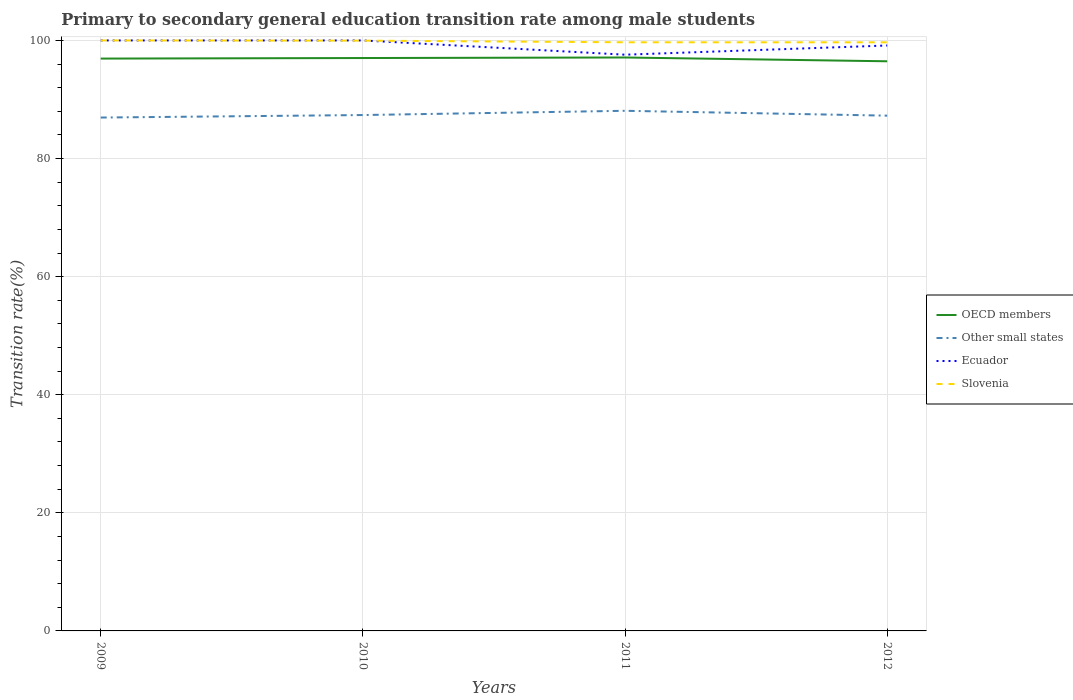How many different coloured lines are there?
Keep it short and to the point. 4. Across all years, what is the maximum transition rate in Ecuador?
Offer a terse response. 97.58. What is the total transition rate in OECD members in the graph?
Provide a succinct answer. 0.46. What is the difference between the highest and the second highest transition rate in Ecuador?
Offer a terse response. 2.42. What is the difference between the highest and the lowest transition rate in OECD members?
Offer a terse response. 3. Is the transition rate in Other small states strictly greater than the transition rate in OECD members over the years?
Provide a short and direct response. Yes. Does the graph contain any zero values?
Your response must be concise. No. Does the graph contain grids?
Provide a short and direct response. Yes. How are the legend labels stacked?
Keep it short and to the point. Vertical. What is the title of the graph?
Ensure brevity in your answer.  Primary to secondary general education transition rate among male students. Does "Panama" appear as one of the legend labels in the graph?
Offer a very short reply. No. What is the label or title of the Y-axis?
Give a very brief answer. Transition rate(%). What is the Transition rate(%) in OECD members in 2009?
Ensure brevity in your answer.  96.93. What is the Transition rate(%) in Other small states in 2009?
Give a very brief answer. 86.94. What is the Transition rate(%) in Ecuador in 2009?
Offer a very short reply. 100. What is the Transition rate(%) in OECD members in 2010?
Your response must be concise. 97.02. What is the Transition rate(%) of Other small states in 2010?
Make the answer very short. 87.36. What is the Transition rate(%) of Ecuador in 2010?
Your answer should be very brief. 100. What is the Transition rate(%) in Slovenia in 2010?
Your answer should be compact. 99.96. What is the Transition rate(%) in OECD members in 2011?
Offer a very short reply. 97.11. What is the Transition rate(%) of Other small states in 2011?
Your response must be concise. 88.09. What is the Transition rate(%) of Ecuador in 2011?
Give a very brief answer. 97.58. What is the Transition rate(%) in Slovenia in 2011?
Offer a terse response. 99.69. What is the Transition rate(%) of OECD members in 2012?
Provide a short and direct response. 96.47. What is the Transition rate(%) of Other small states in 2012?
Your response must be concise. 87.26. What is the Transition rate(%) of Ecuador in 2012?
Give a very brief answer. 99.14. What is the Transition rate(%) of Slovenia in 2012?
Give a very brief answer. 99.68. Across all years, what is the maximum Transition rate(%) of OECD members?
Make the answer very short. 97.11. Across all years, what is the maximum Transition rate(%) in Other small states?
Offer a very short reply. 88.09. Across all years, what is the maximum Transition rate(%) of Ecuador?
Provide a succinct answer. 100. Across all years, what is the maximum Transition rate(%) in Slovenia?
Give a very brief answer. 100. Across all years, what is the minimum Transition rate(%) in OECD members?
Offer a very short reply. 96.47. Across all years, what is the minimum Transition rate(%) in Other small states?
Your answer should be compact. 86.94. Across all years, what is the minimum Transition rate(%) in Ecuador?
Provide a succinct answer. 97.58. Across all years, what is the minimum Transition rate(%) of Slovenia?
Give a very brief answer. 99.68. What is the total Transition rate(%) in OECD members in the graph?
Provide a short and direct response. 387.53. What is the total Transition rate(%) of Other small states in the graph?
Provide a succinct answer. 349.65. What is the total Transition rate(%) of Ecuador in the graph?
Give a very brief answer. 396.73. What is the total Transition rate(%) of Slovenia in the graph?
Provide a succinct answer. 399.33. What is the difference between the Transition rate(%) in OECD members in 2009 and that in 2010?
Make the answer very short. -0.09. What is the difference between the Transition rate(%) of Other small states in 2009 and that in 2010?
Ensure brevity in your answer.  -0.42. What is the difference between the Transition rate(%) of Ecuador in 2009 and that in 2010?
Your answer should be very brief. 0. What is the difference between the Transition rate(%) in Slovenia in 2009 and that in 2010?
Provide a succinct answer. 0.04. What is the difference between the Transition rate(%) of OECD members in 2009 and that in 2011?
Provide a short and direct response. -0.19. What is the difference between the Transition rate(%) in Other small states in 2009 and that in 2011?
Provide a short and direct response. -1.14. What is the difference between the Transition rate(%) of Ecuador in 2009 and that in 2011?
Provide a short and direct response. 2.42. What is the difference between the Transition rate(%) in Slovenia in 2009 and that in 2011?
Your response must be concise. 0.31. What is the difference between the Transition rate(%) of OECD members in 2009 and that in 2012?
Give a very brief answer. 0.46. What is the difference between the Transition rate(%) of Other small states in 2009 and that in 2012?
Keep it short and to the point. -0.32. What is the difference between the Transition rate(%) of Ecuador in 2009 and that in 2012?
Your response must be concise. 0.86. What is the difference between the Transition rate(%) in Slovenia in 2009 and that in 2012?
Ensure brevity in your answer.  0.32. What is the difference between the Transition rate(%) of OECD members in 2010 and that in 2011?
Give a very brief answer. -0.09. What is the difference between the Transition rate(%) in Other small states in 2010 and that in 2011?
Your response must be concise. -0.72. What is the difference between the Transition rate(%) in Ecuador in 2010 and that in 2011?
Your response must be concise. 2.42. What is the difference between the Transition rate(%) of Slovenia in 2010 and that in 2011?
Your answer should be compact. 0.28. What is the difference between the Transition rate(%) of OECD members in 2010 and that in 2012?
Your response must be concise. 0.55. What is the difference between the Transition rate(%) of Other small states in 2010 and that in 2012?
Provide a succinct answer. 0.1. What is the difference between the Transition rate(%) of Ecuador in 2010 and that in 2012?
Give a very brief answer. 0.86. What is the difference between the Transition rate(%) in Slovenia in 2010 and that in 2012?
Offer a very short reply. 0.28. What is the difference between the Transition rate(%) of OECD members in 2011 and that in 2012?
Provide a succinct answer. 0.64. What is the difference between the Transition rate(%) in Other small states in 2011 and that in 2012?
Ensure brevity in your answer.  0.82. What is the difference between the Transition rate(%) of Ecuador in 2011 and that in 2012?
Make the answer very short. -1.56. What is the difference between the Transition rate(%) in Slovenia in 2011 and that in 2012?
Give a very brief answer. 0.01. What is the difference between the Transition rate(%) in OECD members in 2009 and the Transition rate(%) in Other small states in 2010?
Provide a short and direct response. 9.56. What is the difference between the Transition rate(%) in OECD members in 2009 and the Transition rate(%) in Ecuador in 2010?
Provide a short and direct response. -3.07. What is the difference between the Transition rate(%) in OECD members in 2009 and the Transition rate(%) in Slovenia in 2010?
Your response must be concise. -3.04. What is the difference between the Transition rate(%) of Other small states in 2009 and the Transition rate(%) of Ecuador in 2010?
Your answer should be compact. -13.06. What is the difference between the Transition rate(%) of Other small states in 2009 and the Transition rate(%) of Slovenia in 2010?
Your answer should be very brief. -13.02. What is the difference between the Transition rate(%) of Ecuador in 2009 and the Transition rate(%) of Slovenia in 2010?
Offer a terse response. 0.04. What is the difference between the Transition rate(%) in OECD members in 2009 and the Transition rate(%) in Other small states in 2011?
Your answer should be compact. 8.84. What is the difference between the Transition rate(%) of OECD members in 2009 and the Transition rate(%) of Ecuador in 2011?
Your answer should be very brief. -0.66. What is the difference between the Transition rate(%) of OECD members in 2009 and the Transition rate(%) of Slovenia in 2011?
Make the answer very short. -2.76. What is the difference between the Transition rate(%) in Other small states in 2009 and the Transition rate(%) in Ecuador in 2011?
Your response must be concise. -10.64. What is the difference between the Transition rate(%) in Other small states in 2009 and the Transition rate(%) in Slovenia in 2011?
Offer a very short reply. -12.75. What is the difference between the Transition rate(%) of Ecuador in 2009 and the Transition rate(%) of Slovenia in 2011?
Your answer should be very brief. 0.31. What is the difference between the Transition rate(%) of OECD members in 2009 and the Transition rate(%) of Other small states in 2012?
Your answer should be compact. 9.67. What is the difference between the Transition rate(%) in OECD members in 2009 and the Transition rate(%) in Ecuador in 2012?
Give a very brief answer. -2.22. What is the difference between the Transition rate(%) in OECD members in 2009 and the Transition rate(%) in Slovenia in 2012?
Ensure brevity in your answer.  -2.76. What is the difference between the Transition rate(%) in Other small states in 2009 and the Transition rate(%) in Ecuador in 2012?
Give a very brief answer. -12.2. What is the difference between the Transition rate(%) in Other small states in 2009 and the Transition rate(%) in Slovenia in 2012?
Your answer should be compact. -12.74. What is the difference between the Transition rate(%) of Ecuador in 2009 and the Transition rate(%) of Slovenia in 2012?
Your answer should be very brief. 0.32. What is the difference between the Transition rate(%) in OECD members in 2010 and the Transition rate(%) in Other small states in 2011?
Offer a very short reply. 8.94. What is the difference between the Transition rate(%) of OECD members in 2010 and the Transition rate(%) of Ecuador in 2011?
Offer a very short reply. -0.56. What is the difference between the Transition rate(%) in OECD members in 2010 and the Transition rate(%) in Slovenia in 2011?
Offer a terse response. -2.67. What is the difference between the Transition rate(%) of Other small states in 2010 and the Transition rate(%) of Ecuador in 2011?
Provide a succinct answer. -10.22. What is the difference between the Transition rate(%) in Other small states in 2010 and the Transition rate(%) in Slovenia in 2011?
Offer a very short reply. -12.32. What is the difference between the Transition rate(%) of Ecuador in 2010 and the Transition rate(%) of Slovenia in 2011?
Make the answer very short. 0.31. What is the difference between the Transition rate(%) of OECD members in 2010 and the Transition rate(%) of Other small states in 2012?
Provide a succinct answer. 9.76. What is the difference between the Transition rate(%) in OECD members in 2010 and the Transition rate(%) in Ecuador in 2012?
Ensure brevity in your answer.  -2.12. What is the difference between the Transition rate(%) of OECD members in 2010 and the Transition rate(%) of Slovenia in 2012?
Keep it short and to the point. -2.66. What is the difference between the Transition rate(%) in Other small states in 2010 and the Transition rate(%) in Ecuador in 2012?
Provide a short and direct response. -11.78. What is the difference between the Transition rate(%) of Other small states in 2010 and the Transition rate(%) of Slovenia in 2012?
Give a very brief answer. -12.32. What is the difference between the Transition rate(%) of Ecuador in 2010 and the Transition rate(%) of Slovenia in 2012?
Keep it short and to the point. 0.32. What is the difference between the Transition rate(%) of OECD members in 2011 and the Transition rate(%) of Other small states in 2012?
Your response must be concise. 9.85. What is the difference between the Transition rate(%) of OECD members in 2011 and the Transition rate(%) of Ecuador in 2012?
Give a very brief answer. -2.03. What is the difference between the Transition rate(%) of OECD members in 2011 and the Transition rate(%) of Slovenia in 2012?
Your answer should be very brief. -2.57. What is the difference between the Transition rate(%) of Other small states in 2011 and the Transition rate(%) of Ecuador in 2012?
Offer a terse response. -11.06. What is the difference between the Transition rate(%) in Other small states in 2011 and the Transition rate(%) in Slovenia in 2012?
Keep it short and to the point. -11.6. What is the difference between the Transition rate(%) in Ecuador in 2011 and the Transition rate(%) in Slovenia in 2012?
Give a very brief answer. -2.1. What is the average Transition rate(%) in OECD members per year?
Offer a terse response. 96.88. What is the average Transition rate(%) of Other small states per year?
Make the answer very short. 87.41. What is the average Transition rate(%) of Ecuador per year?
Offer a terse response. 99.18. What is the average Transition rate(%) of Slovenia per year?
Offer a very short reply. 99.83. In the year 2009, what is the difference between the Transition rate(%) of OECD members and Transition rate(%) of Other small states?
Provide a succinct answer. 9.99. In the year 2009, what is the difference between the Transition rate(%) of OECD members and Transition rate(%) of Ecuador?
Provide a short and direct response. -3.07. In the year 2009, what is the difference between the Transition rate(%) of OECD members and Transition rate(%) of Slovenia?
Your answer should be very brief. -3.07. In the year 2009, what is the difference between the Transition rate(%) of Other small states and Transition rate(%) of Ecuador?
Give a very brief answer. -13.06. In the year 2009, what is the difference between the Transition rate(%) in Other small states and Transition rate(%) in Slovenia?
Give a very brief answer. -13.06. In the year 2010, what is the difference between the Transition rate(%) of OECD members and Transition rate(%) of Other small states?
Provide a short and direct response. 9.66. In the year 2010, what is the difference between the Transition rate(%) of OECD members and Transition rate(%) of Ecuador?
Provide a short and direct response. -2.98. In the year 2010, what is the difference between the Transition rate(%) in OECD members and Transition rate(%) in Slovenia?
Your answer should be compact. -2.94. In the year 2010, what is the difference between the Transition rate(%) of Other small states and Transition rate(%) of Ecuador?
Provide a succinct answer. -12.64. In the year 2010, what is the difference between the Transition rate(%) in Other small states and Transition rate(%) in Slovenia?
Make the answer very short. -12.6. In the year 2010, what is the difference between the Transition rate(%) in Ecuador and Transition rate(%) in Slovenia?
Ensure brevity in your answer.  0.04. In the year 2011, what is the difference between the Transition rate(%) in OECD members and Transition rate(%) in Other small states?
Make the answer very short. 9.03. In the year 2011, what is the difference between the Transition rate(%) of OECD members and Transition rate(%) of Ecuador?
Give a very brief answer. -0.47. In the year 2011, what is the difference between the Transition rate(%) in OECD members and Transition rate(%) in Slovenia?
Keep it short and to the point. -2.58. In the year 2011, what is the difference between the Transition rate(%) in Other small states and Transition rate(%) in Ecuador?
Give a very brief answer. -9.5. In the year 2011, what is the difference between the Transition rate(%) of Other small states and Transition rate(%) of Slovenia?
Your answer should be very brief. -11.6. In the year 2011, what is the difference between the Transition rate(%) of Ecuador and Transition rate(%) of Slovenia?
Keep it short and to the point. -2.1. In the year 2012, what is the difference between the Transition rate(%) in OECD members and Transition rate(%) in Other small states?
Make the answer very short. 9.21. In the year 2012, what is the difference between the Transition rate(%) in OECD members and Transition rate(%) in Ecuador?
Provide a succinct answer. -2.67. In the year 2012, what is the difference between the Transition rate(%) in OECD members and Transition rate(%) in Slovenia?
Your answer should be very brief. -3.21. In the year 2012, what is the difference between the Transition rate(%) of Other small states and Transition rate(%) of Ecuador?
Your response must be concise. -11.88. In the year 2012, what is the difference between the Transition rate(%) of Other small states and Transition rate(%) of Slovenia?
Ensure brevity in your answer.  -12.42. In the year 2012, what is the difference between the Transition rate(%) of Ecuador and Transition rate(%) of Slovenia?
Your answer should be compact. -0.54. What is the ratio of the Transition rate(%) of Other small states in 2009 to that in 2010?
Give a very brief answer. 1. What is the ratio of the Transition rate(%) in Slovenia in 2009 to that in 2010?
Provide a short and direct response. 1. What is the ratio of the Transition rate(%) of Ecuador in 2009 to that in 2011?
Make the answer very short. 1.02. What is the ratio of the Transition rate(%) of Ecuador in 2009 to that in 2012?
Provide a succinct answer. 1.01. What is the ratio of the Transition rate(%) in Slovenia in 2009 to that in 2012?
Make the answer very short. 1. What is the ratio of the Transition rate(%) in OECD members in 2010 to that in 2011?
Keep it short and to the point. 1. What is the ratio of the Transition rate(%) of Ecuador in 2010 to that in 2011?
Your response must be concise. 1.02. What is the ratio of the Transition rate(%) of Slovenia in 2010 to that in 2011?
Keep it short and to the point. 1. What is the ratio of the Transition rate(%) in Ecuador in 2010 to that in 2012?
Your answer should be very brief. 1.01. What is the ratio of the Transition rate(%) of Slovenia in 2010 to that in 2012?
Your response must be concise. 1. What is the ratio of the Transition rate(%) in OECD members in 2011 to that in 2012?
Provide a succinct answer. 1.01. What is the ratio of the Transition rate(%) in Other small states in 2011 to that in 2012?
Provide a succinct answer. 1.01. What is the ratio of the Transition rate(%) of Ecuador in 2011 to that in 2012?
Provide a succinct answer. 0.98. What is the ratio of the Transition rate(%) in Slovenia in 2011 to that in 2012?
Your answer should be very brief. 1. What is the difference between the highest and the second highest Transition rate(%) of OECD members?
Your answer should be very brief. 0.09. What is the difference between the highest and the second highest Transition rate(%) of Other small states?
Offer a very short reply. 0.72. What is the difference between the highest and the second highest Transition rate(%) in Ecuador?
Your answer should be compact. 0. What is the difference between the highest and the second highest Transition rate(%) in Slovenia?
Make the answer very short. 0.04. What is the difference between the highest and the lowest Transition rate(%) in OECD members?
Your answer should be compact. 0.64. What is the difference between the highest and the lowest Transition rate(%) of Other small states?
Your response must be concise. 1.14. What is the difference between the highest and the lowest Transition rate(%) in Ecuador?
Your answer should be compact. 2.42. What is the difference between the highest and the lowest Transition rate(%) of Slovenia?
Offer a very short reply. 0.32. 